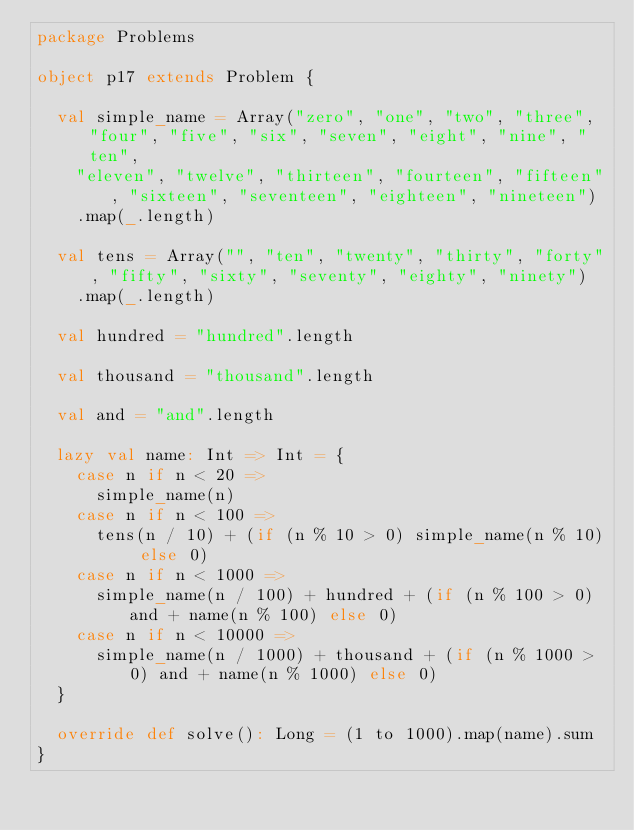Convert code to text. <code><loc_0><loc_0><loc_500><loc_500><_Scala_>package Problems

object p17 extends Problem {
  
  val simple_name = Array("zero", "one", "two", "three", "four", "five", "six", "seven", "eight", "nine", "ten",
    "eleven", "twelve", "thirteen", "fourteen", "fifteen", "sixteen", "seventeen", "eighteen", "nineteen")
    .map(_.length)
  
  val tens = Array("", "ten", "twenty", "thirty", "forty", "fifty", "sixty", "seventy", "eighty", "ninety")
    .map(_.length)
  
  val hundred = "hundred".length
  
  val thousand = "thousand".length
  
  val and = "and".length
  
  lazy val name: Int => Int = {
    case n if n < 20 =>
      simple_name(n)
    case n if n < 100 =>
      tens(n / 10) + (if (n % 10 > 0) simple_name(n % 10) else 0)
    case n if n < 1000 =>
      simple_name(n / 100) + hundred + (if (n % 100 > 0) and + name(n % 100) else 0)
    case n if n < 10000 =>
      simple_name(n / 1000) + thousand + (if (n % 1000 > 0) and + name(n % 1000) else 0)
  }
  
  override def solve(): Long = (1 to 1000).map(name).sum
}
</code> 